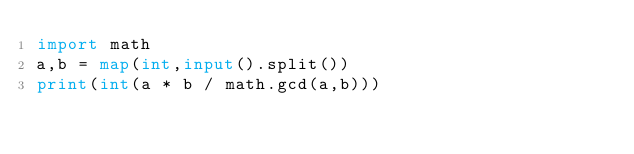Convert code to text. <code><loc_0><loc_0><loc_500><loc_500><_Python_>import math
a,b = map(int,input().split())
print(int(a * b / math.gcd(a,b)))</code> 